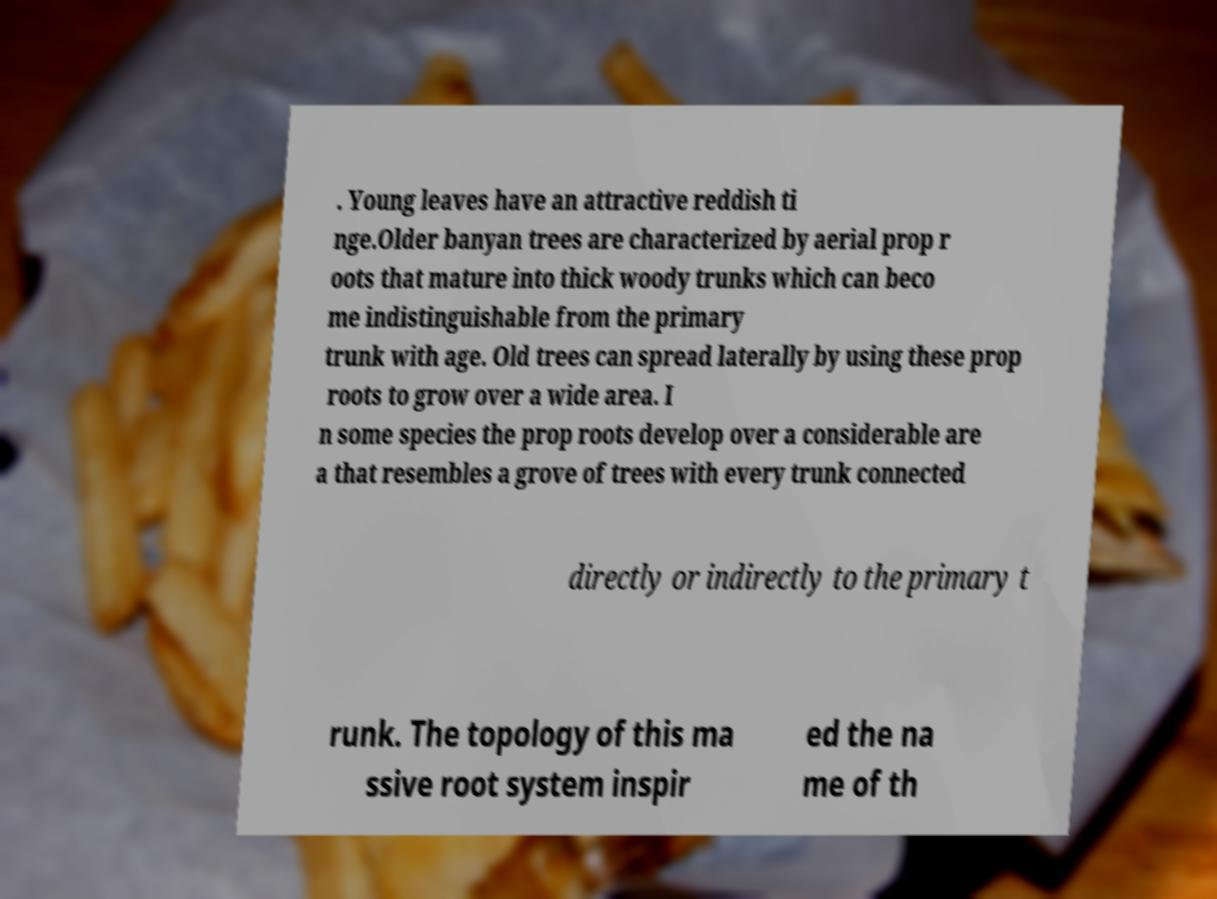For documentation purposes, I need the text within this image transcribed. Could you provide that? . Young leaves have an attractive reddish ti nge.Older banyan trees are characterized by aerial prop r oots that mature into thick woody trunks which can beco me indistinguishable from the primary trunk with age. Old trees can spread laterally by using these prop roots to grow over a wide area. I n some species the prop roots develop over a considerable are a that resembles a grove of trees with every trunk connected directly or indirectly to the primary t runk. The topology of this ma ssive root system inspir ed the na me of th 